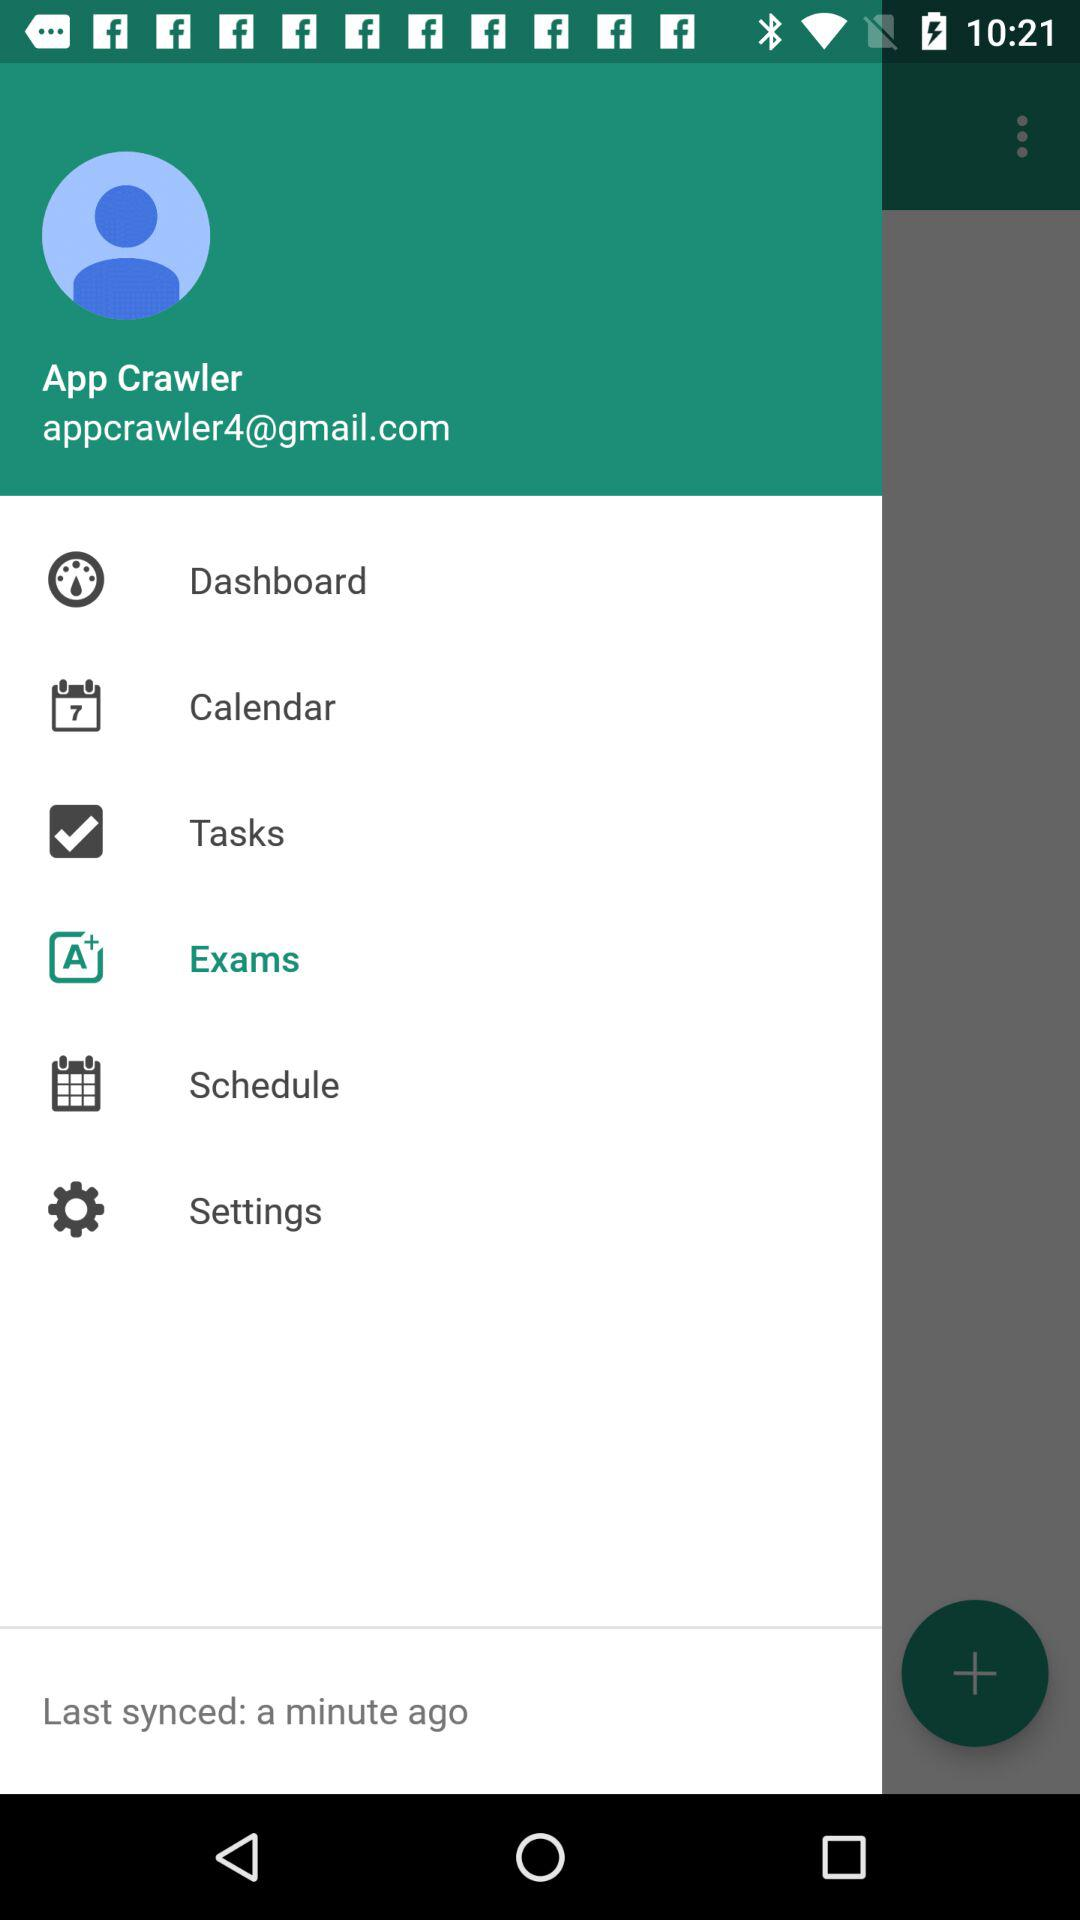What is the email address? The email address is "appcrawler4@gmail.com". 